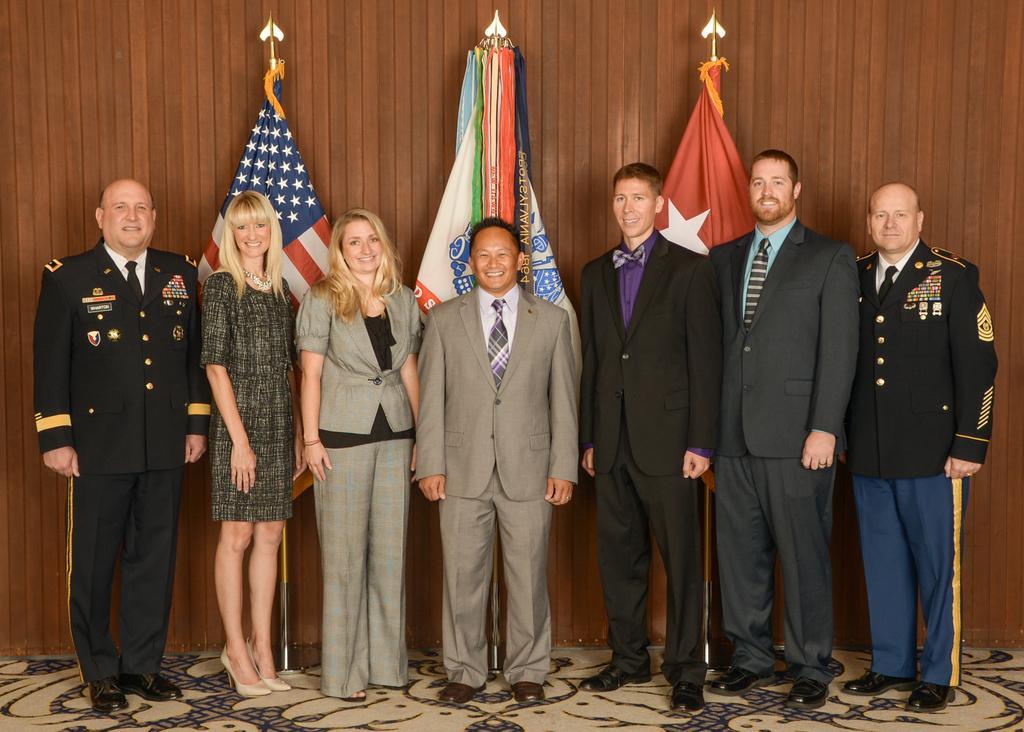Can you describe this image briefly? This picture might be taken inside the room. In this image, there are group of people standing on the floor. In the background, we can see three flags and a wood wall. 